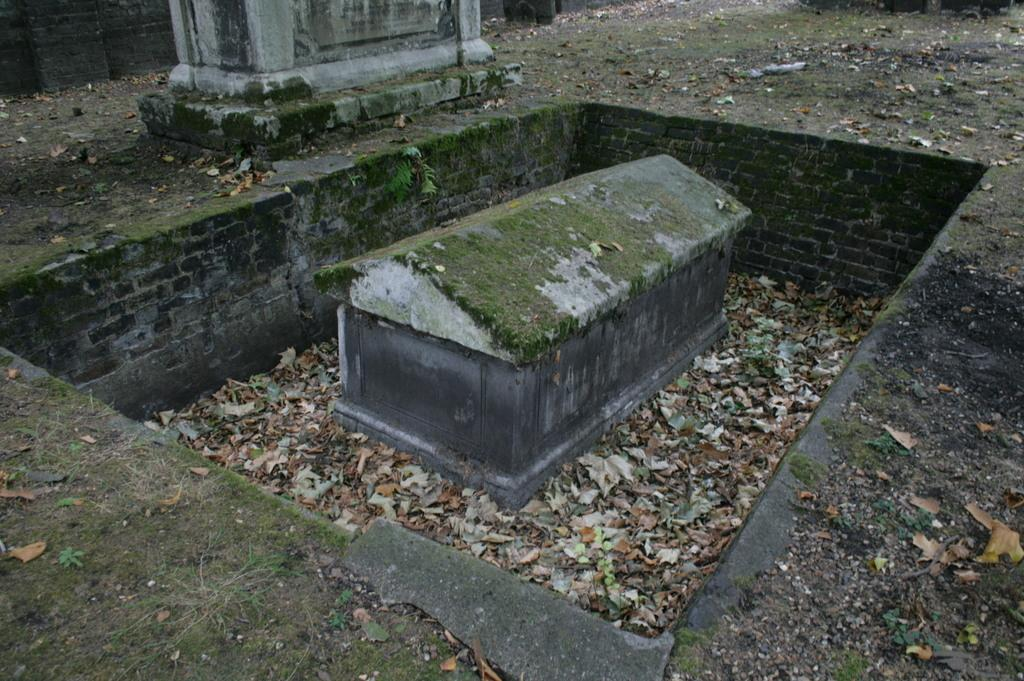What is the main subject in the center of the image? There is a gravestone in the center of the image. What type of vegetation can be seen in the image? There are dried leaves in the image. What type of ground cover is present at the bottom of the image? There is grass at the bottom of the image. Can you see a hen smiling in the image? There is no hen or any indication of a smile in the image. 